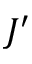Convert formula to latex. <formula><loc_0><loc_0><loc_500><loc_500>J ^ { \prime }</formula> 